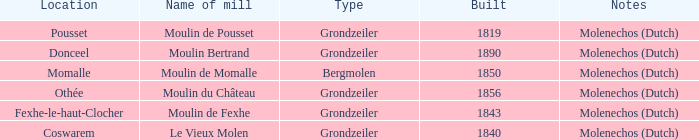What is the Location of the Moulin Bertrand Mill? Donceel. 